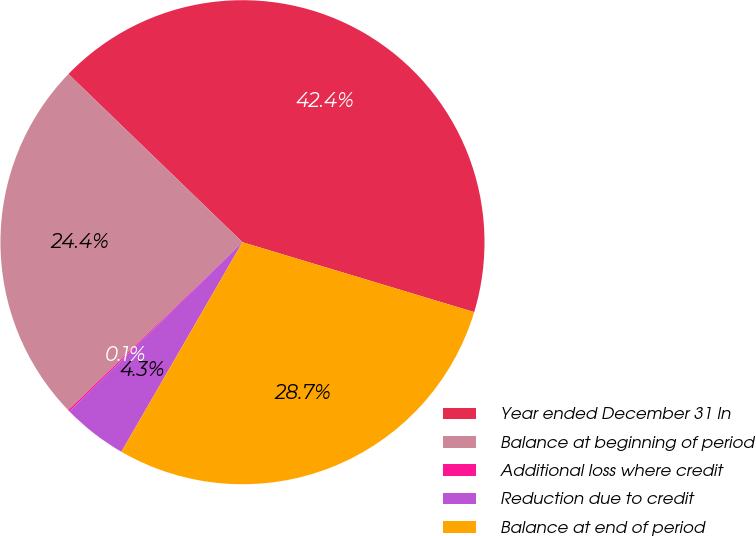Convert chart to OTSL. <chart><loc_0><loc_0><loc_500><loc_500><pie_chart><fcel>Year ended December 31 In<fcel>Balance at beginning of period<fcel>Additional loss where credit<fcel>Reduction due to credit<fcel>Balance at end of period<nl><fcel>42.44%<fcel>24.44%<fcel>0.11%<fcel>4.34%<fcel>28.68%<nl></chart> 